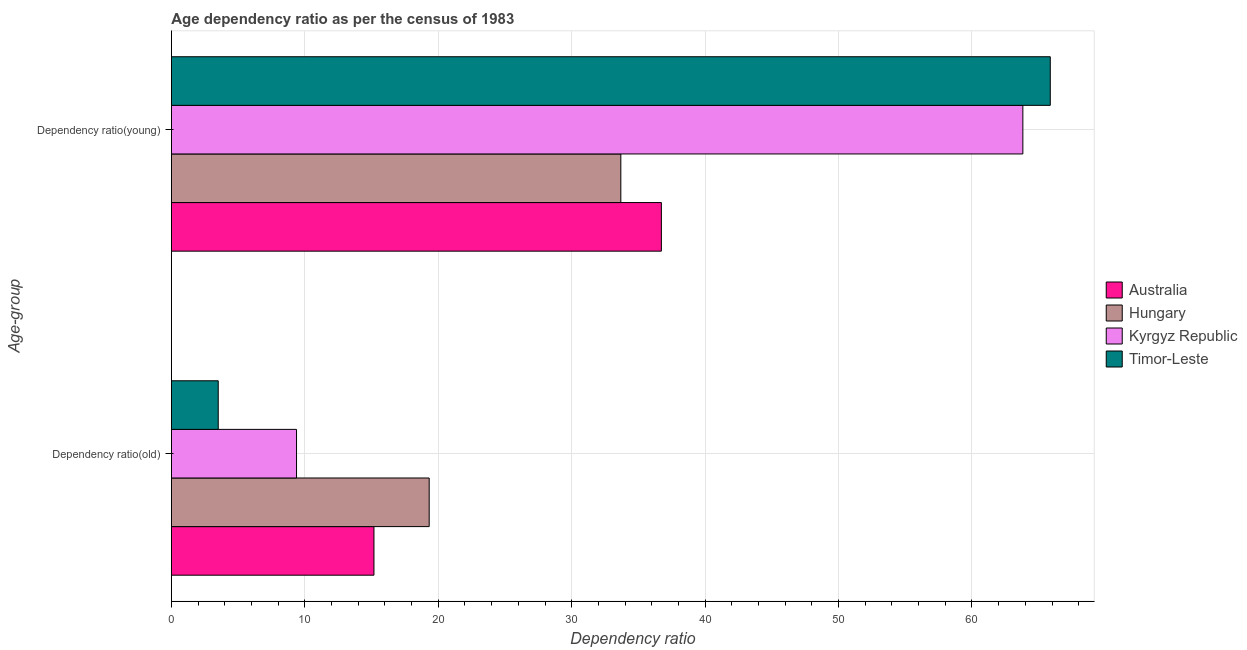How many different coloured bars are there?
Offer a very short reply. 4. How many groups of bars are there?
Provide a succinct answer. 2. Are the number of bars per tick equal to the number of legend labels?
Provide a succinct answer. Yes. How many bars are there on the 2nd tick from the top?
Provide a succinct answer. 4. How many bars are there on the 2nd tick from the bottom?
Provide a succinct answer. 4. What is the label of the 2nd group of bars from the top?
Your answer should be compact. Dependency ratio(old). What is the age dependency ratio(old) in Timor-Leste?
Your response must be concise. 3.51. Across all countries, what is the maximum age dependency ratio(old)?
Ensure brevity in your answer.  19.32. Across all countries, what is the minimum age dependency ratio(old)?
Ensure brevity in your answer.  3.51. In which country was the age dependency ratio(young) maximum?
Provide a succinct answer. Timor-Leste. In which country was the age dependency ratio(old) minimum?
Make the answer very short. Timor-Leste. What is the total age dependency ratio(young) in the graph?
Offer a terse response. 200.09. What is the difference between the age dependency ratio(young) in Kyrgyz Republic and that in Australia?
Your answer should be very brief. 27.09. What is the difference between the age dependency ratio(old) in Australia and the age dependency ratio(young) in Hungary?
Keep it short and to the point. -18.5. What is the average age dependency ratio(young) per country?
Your answer should be compact. 50.02. What is the difference between the age dependency ratio(young) and age dependency ratio(old) in Hungary?
Give a very brief answer. 14.36. In how many countries, is the age dependency ratio(old) greater than 34 ?
Provide a succinct answer. 0. What is the ratio of the age dependency ratio(old) in Timor-Leste to that in Kyrgyz Republic?
Provide a short and direct response. 0.37. Is the age dependency ratio(old) in Timor-Leste less than that in Australia?
Your response must be concise. Yes. What does the 2nd bar from the top in Dependency ratio(young) represents?
Your response must be concise. Kyrgyz Republic. What does the 2nd bar from the bottom in Dependency ratio(old) represents?
Your response must be concise. Hungary. Are all the bars in the graph horizontal?
Your answer should be compact. Yes. What is the difference between two consecutive major ticks on the X-axis?
Provide a succinct answer. 10. Does the graph contain any zero values?
Your answer should be very brief. No. What is the title of the graph?
Your response must be concise. Age dependency ratio as per the census of 1983. What is the label or title of the X-axis?
Provide a succinct answer. Dependency ratio. What is the label or title of the Y-axis?
Provide a short and direct response. Age-group. What is the Dependency ratio in Australia in Dependency ratio(old)?
Offer a very short reply. 15.18. What is the Dependency ratio in Hungary in Dependency ratio(old)?
Keep it short and to the point. 19.32. What is the Dependency ratio of Kyrgyz Republic in Dependency ratio(old)?
Your response must be concise. 9.38. What is the Dependency ratio of Timor-Leste in Dependency ratio(old)?
Your answer should be compact. 3.51. What is the Dependency ratio of Australia in Dependency ratio(young)?
Your answer should be compact. 36.72. What is the Dependency ratio in Hungary in Dependency ratio(young)?
Give a very brief answer. 33.68. What is the Dependency ratio of Kyrgyz Republic in Dependency ratio(young)?
Provide a short and direct response. 63.81. What is the Dependency ratio of Timor-Leste in Dependency ratio(young)?
Offer a terse response. 65.87. Across all Age-group, what is the maximum Dependency ratio in Australia?
Keep it short and to the point. 36.72. Across all Age-group, what is the maximum Dependency ratio in Hungary?
Ensure brevity in your answer.  33.68. Across all Age-group, what is the maximum Dependency ratio in Kyrgyz Republic?
Your answer should be very brief. 63.81. Across all Age-group, what is the maximum Dependency ratio in Timor-Leste?
Keep it short and to the point. 65.87. Across all Age-group, what is the minimum Dependency ratio of Australia?
Ensure brevity in your answer.  15.18. Across all Age-group, what is the minimum Dependency ratio in Hungary?
Make the answer very short. 19.32. Across all Age-group, what is the minimum Dependency ratio in Kyrgyz Republic?
Give a very brief answer. 9.38. Across all Age-group, what is the minimum Dependency ratio in Timor-Leste?
Offer a very short reply. 3.51. What is the total Dependency ratio in Australia in the graph?
Offer a terse response. 51.9. What is the total Dependency ratio of Hungary in the graph?
Your answer should be compact. 53. What is the total Dependency ratio of Kyrgyz Republic in the graph?
Make the answer very short. 73.19. What is the total Dependency ratio in Timor-Leste in the graph?
Ensure brevity in your answer.  69.38. What is the difference between the Dependency ratio of Australia in Dependency ratio(old) and that in Dependency ratio(young)?
Offer a terse response. -21.54. What is the difference between the Dependency ratio in Hungary in Dependency ratio(old) and that in Dependency ratio(young)?
Your response must be concise. -14.36. What is the difference between the Dependency ratio of Kyrgyz Republic in Dependency ratio(old) and that in Dependency ratio(young)?
Provide a succinct answer. -54.43. What is the difference between the Dependency ratio in Timor-Leste in Dependency ratio(old) and that in Dependency ratio(young)?
Provide a short and direct response. -62.36. What is the difference between the Dependency ratio of Australia in Dependency ratio(old) and the Dependency ratio of Hungary in Dependency ratio(young)?
Keep it short and to the point. -18.5. What is the difference between the Dependency ratio in Australia in Dependency ratio(old) and the Dependency ratio in Kyrgyz Republic in Dependency ratio(young)?
Your response must be concise. -48.63. What is the difference between the Dependency ratio of Australia in Dependency ratio(old) and the Dependency ratio of Timor-Leste in Dependency ratio(young)?
Offer a terse response. -50.69. What is the difference between the Dependency ratio in Hungary in Dependency ratio(old) and the Dependency ratio in Kyrgyz Republic in Dependency ratio(young)?
Ensure brevity in your answer.  -44.49. What is the difference between the Dependency ratio in Hungary in Dependency ratio(old) and the Dependency ratio in Timor-Leste in Dependency ratio(young)?
Your answer should be compact. -46.55. What is the difference between the Dependency ratio of Kyrgyz Republic in Dependency ratio(old) and the Dependency ratio of Timor-Leste in Dependency ratio(young)?
Ensure brevity in your answer.  -56.49. What is the average Dependency ratio in Australia per Age-group?
Give a very brief answer. 25.95. What is the average Dependency ratio of Hungary per Age-group?
Provide a short and direct response. 26.5. What is the average Dependency ratio in Kyrgyz Republic per Age-group?
Give a very brief answer. 36.6. What is the average Dependency ratio of Timor-Leste per Age-group?
Keep it short and to the point. 34.69. What is the difference between the Dependency ratio in Australia and Dependency ratio in Hungary in Dependency ratio(old)?
Your response must be concise. -4.14. What is the difference between the Dependency ratio in Australia and Dependency ratio in Kyrgyz Republic in Dependency ratio(old)?
Make the answer very short. 5.8. What is the difference between the Dependency ratio in Australia and Dependency ratio in Timor-Leste in Dependency ratio(old)?
Make the answer very short. 11.67. What is the difference between the Dependency ratio in Hungary and Dependency ratio in Kyrgyz Republic in Dependency ratio(old)?
Your answer should be very brief. 9.94. What is the difference between the Dependency ratio of Hungary and Dependency ratio of Timor-Leste in Dependency ratio(old)?
Your response must be concise. 15.81. What is the difference between the Dependency ratio in Kyrgyz Republic and Dependency ratio in Timor-Leste in Dependency ratio(old)?
Your answer should be compact. 5.87. What is the difference between the Dependency ratio in Australia and Dependency ratio in Hungary in Dependency ratio(young)?
Ensure brevity in your answer.  3.04. What is the difference between the Dependency ratio in Australia and Dependency ratio in Kyrgyz Republic in Dependency ratio(young)?
Provide a succinct answer. -27.09. What is the difference between the Dependency ratio in Australia and Dependency ratio in Timor-Leste in Dependency ratio(young)?
Keep it short and to the point. -29.15. What is the difference between the Dependency ratio in Hungary and Dependency ratio in Kyrgyz Republic in Dependency ratio(young)?
Your answer should be compact. -30.13. What is the difference between the Dependency ratio of Hungary and Dependency ratio of Timor-Leste in Dependency ratio(young)?
Ensure brevity in your answer.  -32.18. What is the difference between the Dependency ratio of Kyrgyz Republic and Dependency ratio of Timor-Leste in Dependency ratio(young)?
Provide a succinct answer. -2.06. What is the ratio of the Dependency ratio of Australia in Dependency ratio(old) to that in Dependency ratio(young)?
Offer a terse response. 0.41. What is the ratio of the Dependency ratio of Hungary in Dependency ratio(old) to that in Dependency ratio(young)?
Provide a succinct answer. 0.57. What is the ratio of the Dependency ratio in Kyrgyz Republic in Dependency ratio(old) to that in Dependency ratio(young)?
Provide a short and direct response. 0.15. What is the ratio of the Dependency ratio in Timor-Leste in Dependency ratio(old) to that in Dependency ratio(young)?
Your answer should be very brief. 0.05. What is the difference between the highest and the second highest Dependency ratio of Australia?
Ensure brevity in your answer.  21.54. What is the difference between the highest and the second highest Dependency ratio of Hungary?
Your answer should be very brief. 14.36. What is the difference between the highest and the second highest Dependency ratio in Kyrgyz Republic?
Keep it short and to the point. 54.43. What is the difference between the highest and the second highest Dependency ratio in Timor-Leste?
Provide a short and direct response. 62.36. What is the difference between the highest and the lowest Dependency ratio of Australia?
Provide a succinct answer. 21.54. What is the difference between the highest and the lowest Dependency ratio of Hungary?
Your answer should be compact. 14.36. What is the difference between the highest and the lowest Dependency ratio of Kyrgyz Republic?
Your answer should be compact. 54.43. What is the difference between the highest and the lowest Dependency ratio of Timor-Leste?
Offer a very short reply. 62.36. 